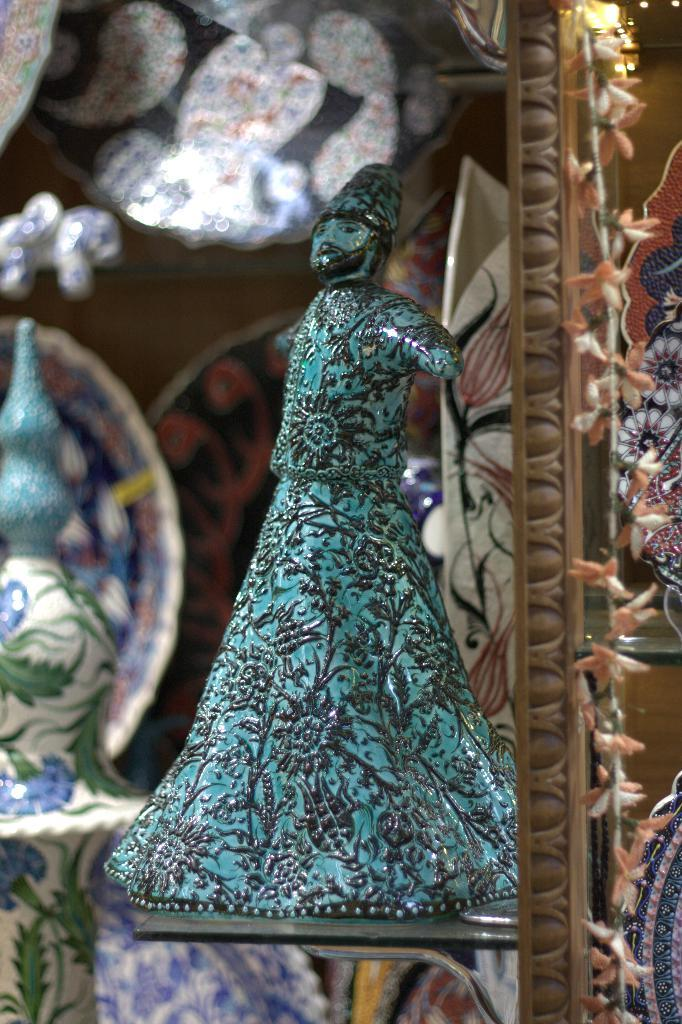What is the main object in the image? There is a toy in the image. Where is the toy located? The toy is placed in a rack. What can be seen on the right side of the image? There are objects on the right side of the image. What type of objects are visible in the background of the image? There are ceramic bowls in the background of the image. Where is the snake located in the image? There is no snake present in the image. What type of lunchroom can be seen in the image? There is no lunchroom present in the image. 